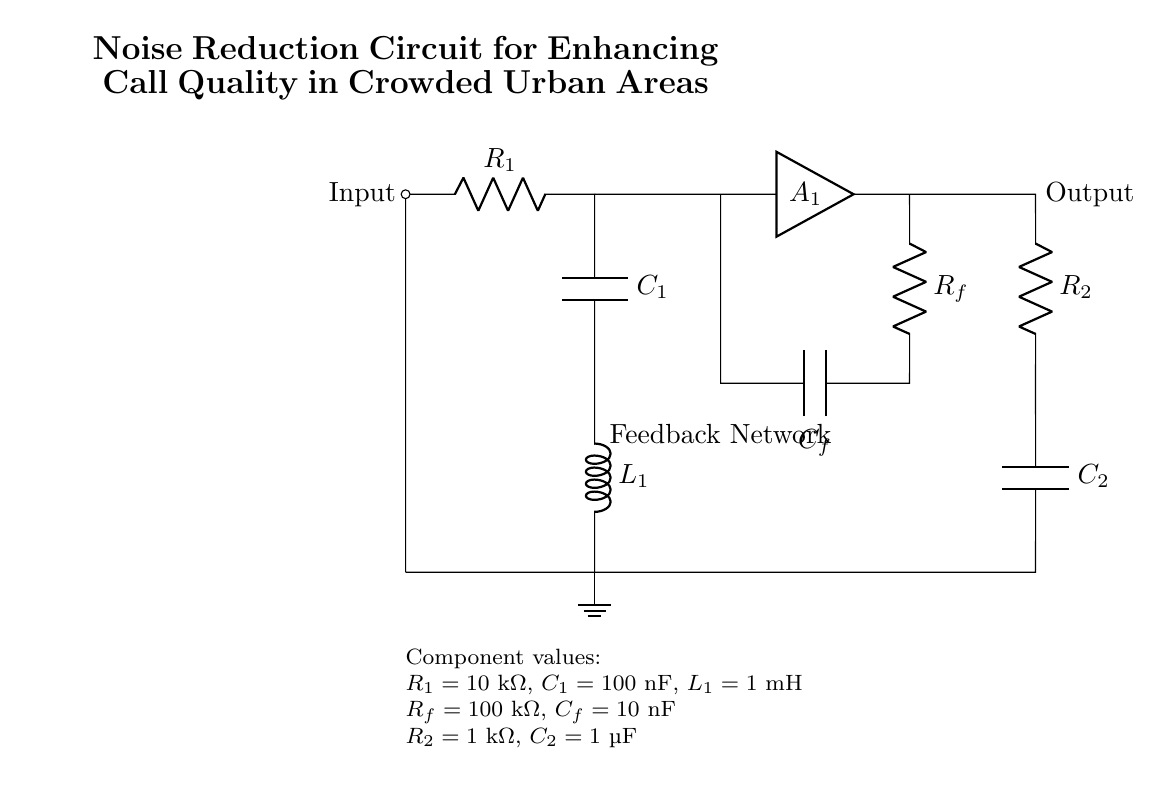What is the input component of the circuit? The input component identified in the circuit diagram is a resistor denoted as R1, which is connected to the input node.
Answer: R1 What is the value of capacitor C1? The circuit diagram displays the value of capacitor C1 as 100 nanofarads, indicated next to the component C1.
Answer: 100 nanofarads What is the purpose of the feedback network? The feedback network, composed of resistor Rf and capacitor Cf, is used to enhance stability and control gain in the amplifier circuit. It connects back from the output, indicating its role in managing the signal quality.
Answer: Control gain What type of circuit is this? The overall structure of this circuit is identified as a noise reduction circuit, designed specifically to enhance call quality in crowded urban areas, as specified in the title of the circuit.
Answer: Noise reduction circuit What are the total resistances in the circuit? To find the total resistances, R1 (10 kOhm), Rf (100 kOhm), and R2 (1 kOhm) should be noted; however, they are not in a series or parallel combination, so their effects are separate in this configuration. Thus, we acknowledge their individual values for circuit performance at different points.
Answer: Varies by section How does the inductor L1 affect the circuit? The inductor L1, which has a value of 1 mH, contributes to filtering and helps manage the frequency response of the circuit, providing inductive reactance that can stabilize the circuit against noise fluctuations. Its presence impacts how well the circuit can handle varying noise scenarios.
Answer: Filters noise What determines the output capacitor's value, C2? Capacitor C2 plays a crucial role in determining the output characteristics, set at 1 microfarad. This value influences the low-frequency response, ensuring that desired signals can pass while blocking unwanted interference from the output end of the circuit.
Answer: 1 microfarad 